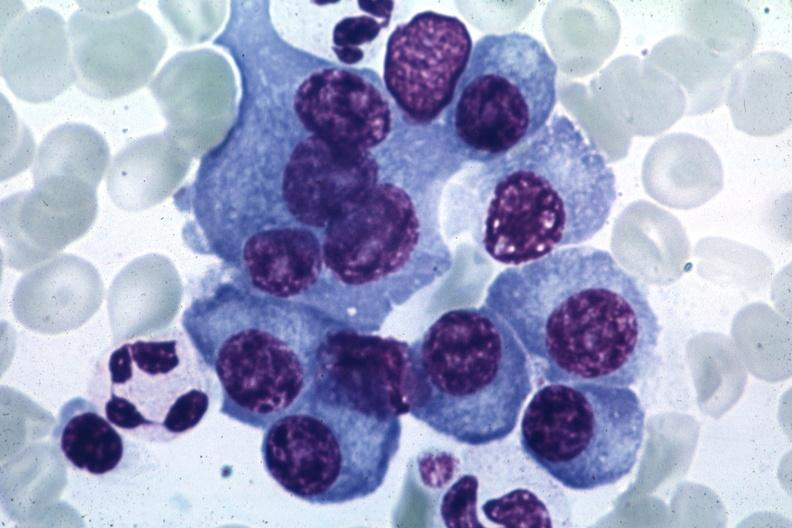what is present?
Answer the question using a single word or phrase. Bone marrow 